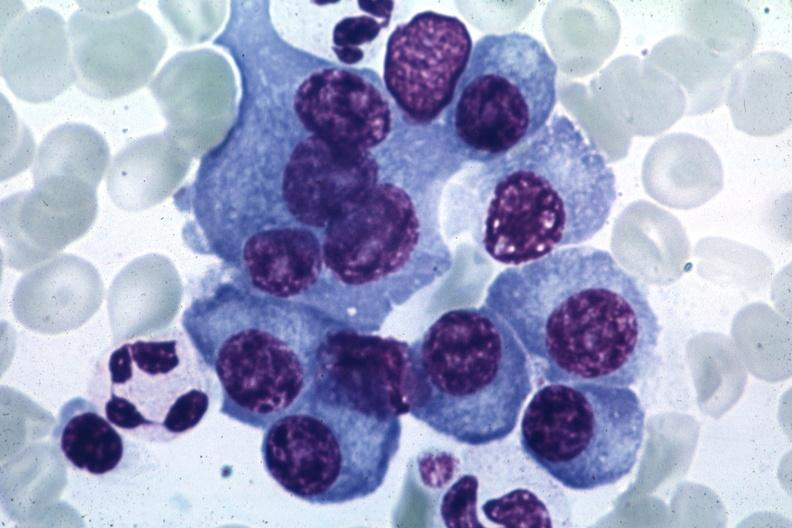what is present?
Answer the question using a single word or phrase. Bone marrow 